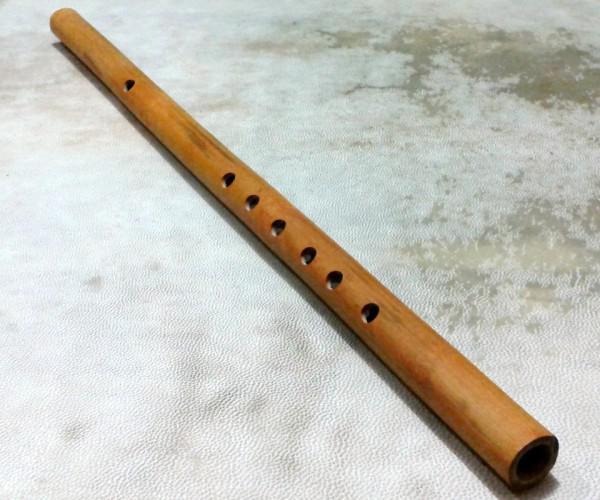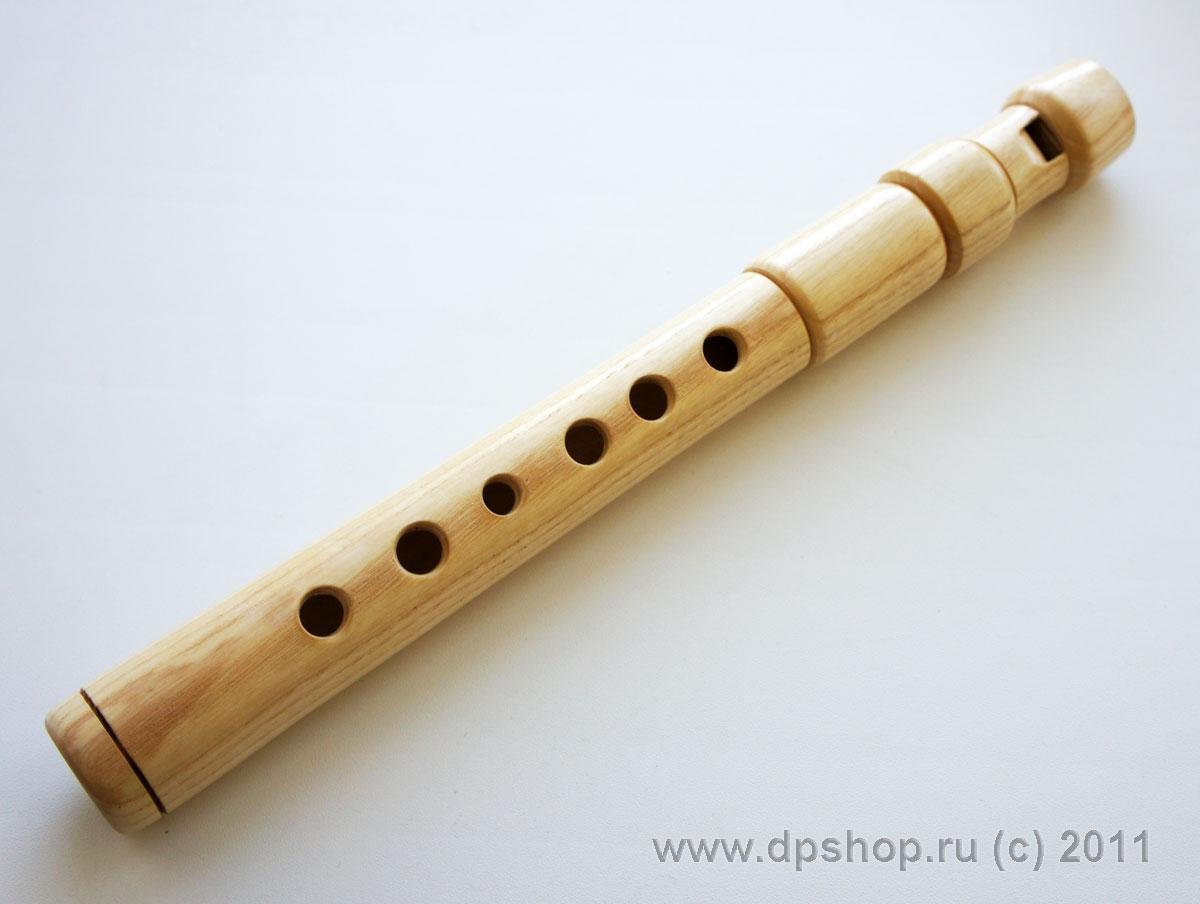The first image is the image on the left, the second image is the image on the right. Evaluate the accuracy of this statement regarding the images: "The left image contains a single wooden flute displayed diagonally with one end at the upper right, and the right image features multiple flutes displayed diagonally at the opposite angle.". Is it true? Answer yes or no. No. The first image is the image on the left, the second image is the image on the right. For the images shown, is this caption "There is more than one wooden musical instrument in the right image and exactly one on the left." true? Answer yes or no. No. 